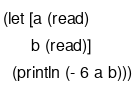<code> <loc_0><loc_0><loc_500><loc_500><_Clojure_>(let [a (read)
      b (read)]
  (println (- 6 a b)))
</code> 